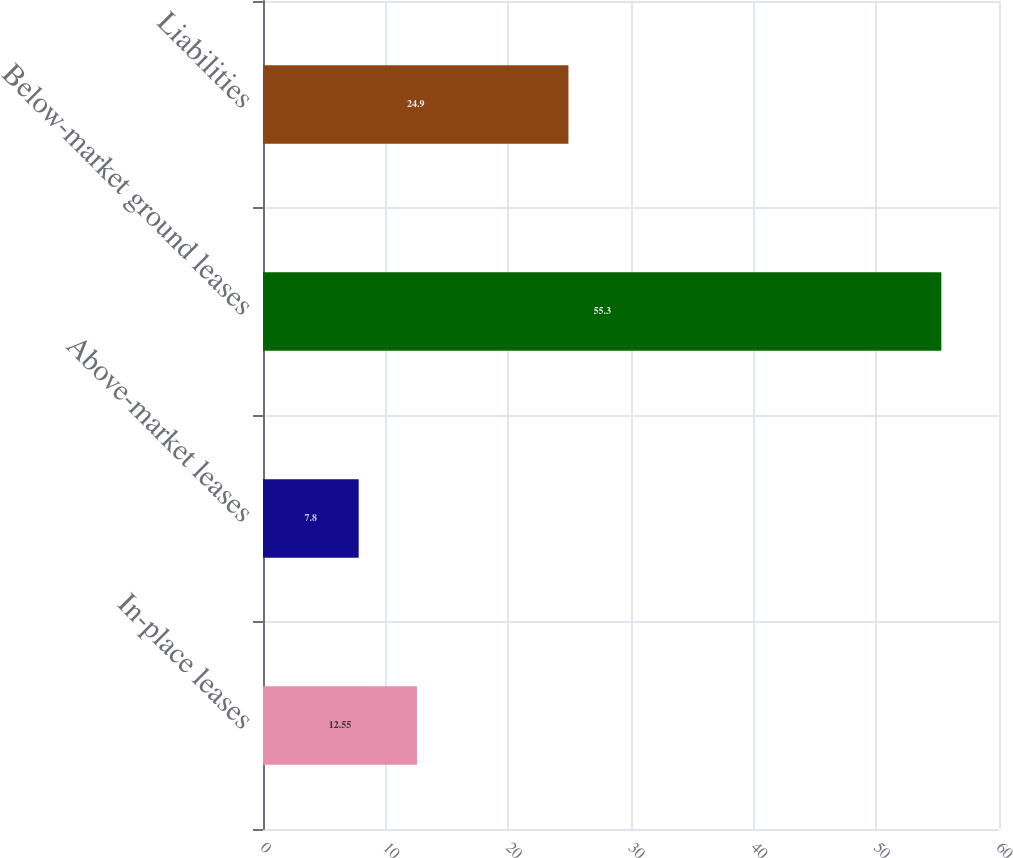<chart> <loc_0><loc_0><loc_500><loc_500><bar_chart><fcel>In-place leases<fcel>Above-market leases<fcel>Below-market ground leases<fcel>Liabilities<nl><fcel>12.55<fcel>7.8<fcel>55.3<fcel>24.9<nl></chart> 